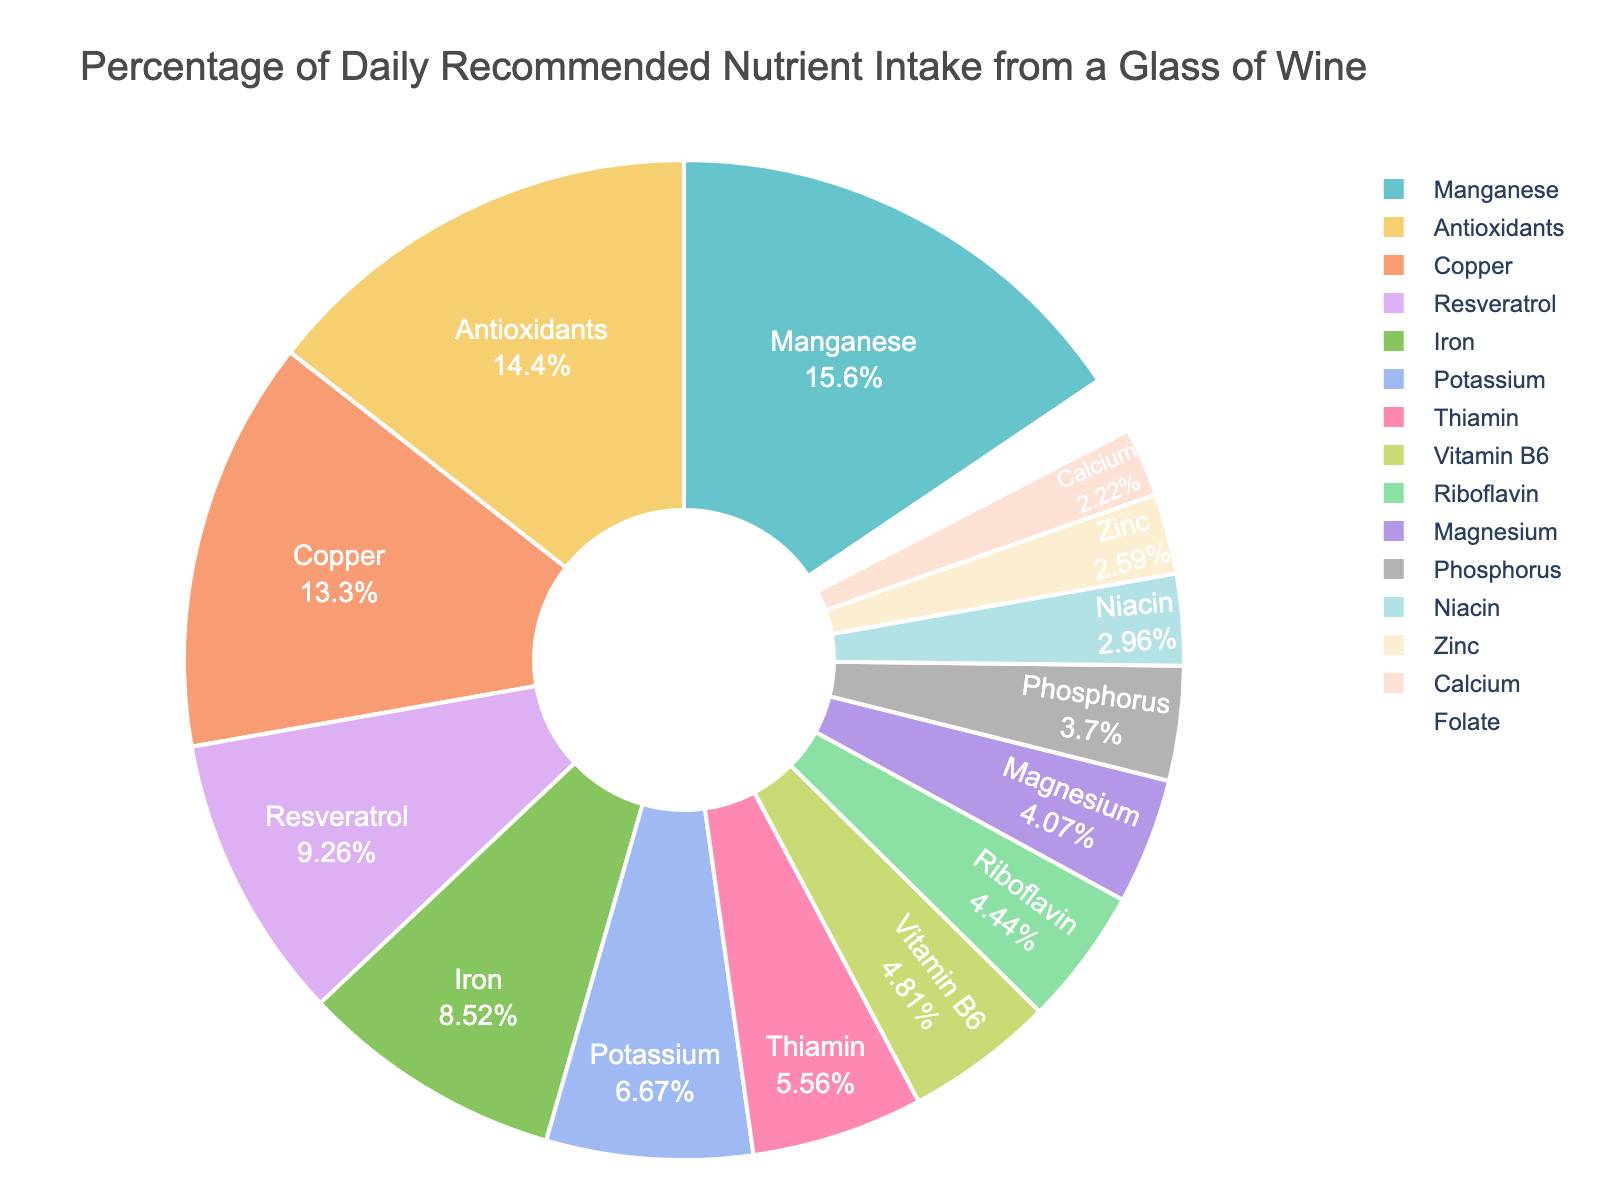Which nutrient provides the highest percentage of the daily recommended intake from a glass of wine? Look for the largest portion in the pie chart and read the corresponding label.
Answer: Manganese What is the combined percentage of daily recommended intake for Antioxidants, Copper, and Resveratrol from a glass of wine? Find the individual percentages for Antioxidants (3.9%), Copper (3.6%), and Resveratrol (2.5%) and add them together: 3.9 + 3.6 + 2.5 = 10
Answer: 10 Is the percentage of daily recommended intake for Iron greater than that for Thiamin? Compare the slices of the pie chart for Iron (2.3%) and Thiamin (1.5%). Since 2.3 > 1.5, Iron has a higher percentage.
Answer: Yes How does the percentage of daily recommended intake for Magnesium compare to that of Riboflavin? Locate the slices for Magnesium (1.1%) and Riboflavin (1.2%) and compare them. Since 1.1 < 1.2, Riboflavin is slightly higher.
Answer: Riboflavin is higher Which nutrient has the smallest contribution to the daily recommended intake, and what is its value? Find the smallest slice in the pie chart and read off its label and value.
Answer: Folate, 0.5 